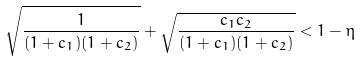Convert formula to latex. <formula><loc_0><loc_0><loc_500><loc_500>\sqrt { \frac { 1 } { ( 1 + c _ { 1 } ) ( 1 + c _ { 2 } ) } } + \sqrt { \frac { c _ { 1 } c _ { 2 } } { ( 1 + c _ { 1 } ) ( 1 + c _ { 2 } ) } } < 1 - \eta</formula> 